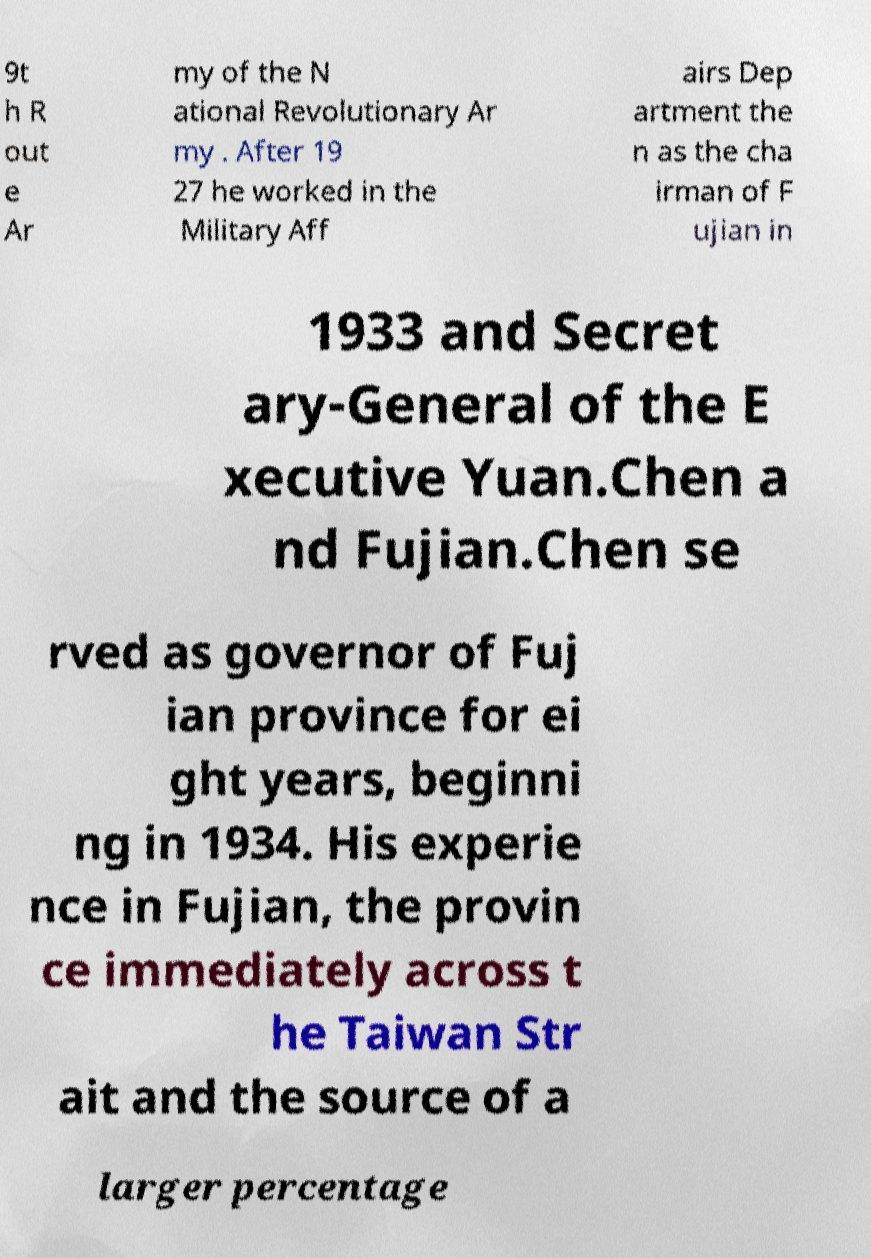Please identify and transcribe the text found in this image. 9t h R out e Ar my of the N ational Revolutionary Ar my . After 19 27 he worked in the Military Aff airs Dep artment the n as the cha irman of F ujian in 1933 and Secret ary-General of the E xecutive Yuan.Chen a nd Fujian.Chen se rved as governor of Fuj ian province for ei ght years, beginni ng in 1934. His experie nce in Fujian, the provin ce immediately across t he Taiwan Str ait and the source of a larger percentage 